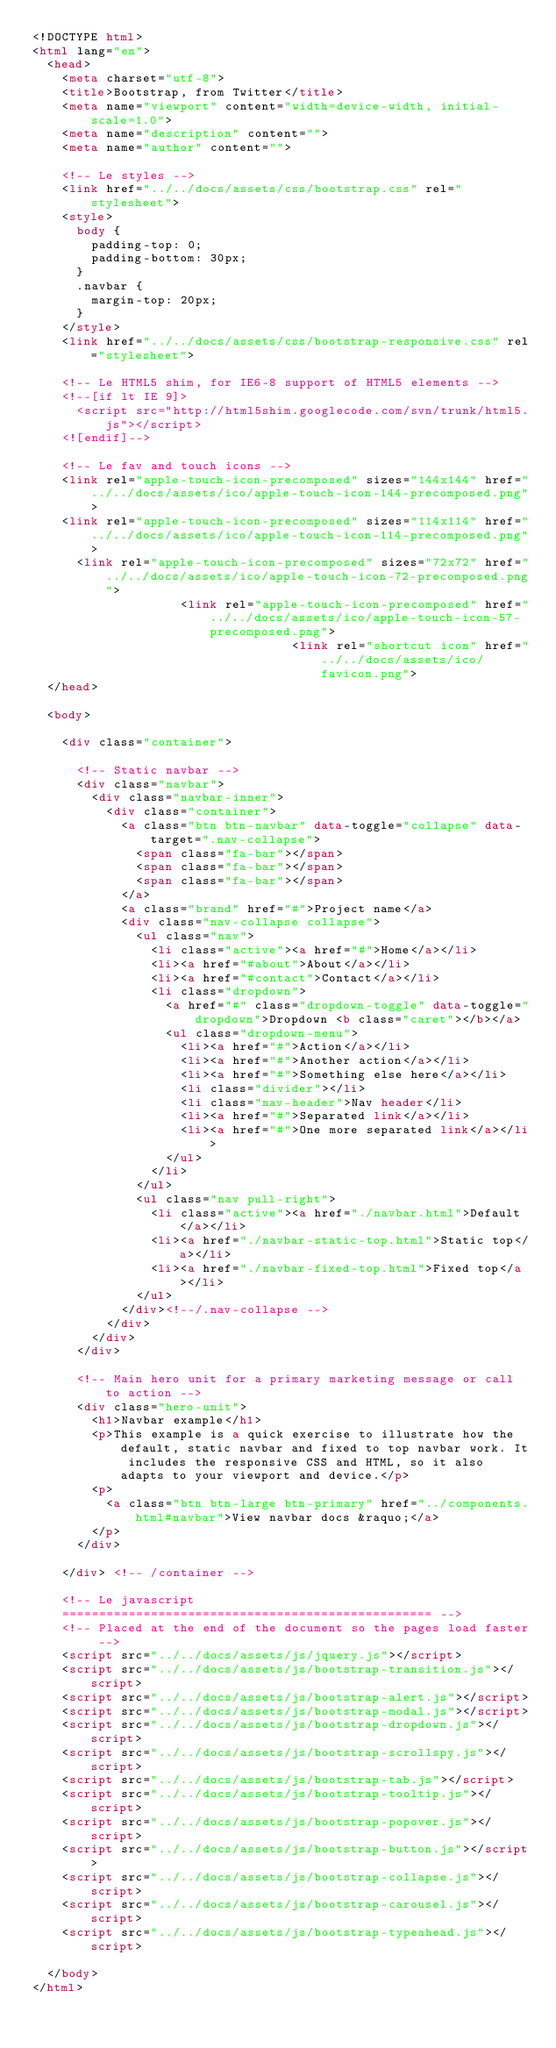Convert code to text. <code><loc_0><loc_0><loc_500><loc_500><_HTML_><!DOCTYPE html>
<html lang="en">
  <head>
    <meta charset="utf-8">
    <title>Bootstrap, from Twitter</title>
    <meta name="viewport" content="width=device-width, initial-scale=1.0">
    <meta name="description" content="">
    <meta name="author" content="">

    <!-- Le styles -->
    <link href="../../docs/assets/css/bootstrap.css" rel="stylesheet">
    <style>
      body {
        padding-top: 0;
        padding-bottom: 30px;
      }
      .navbar {
        margin-top: 20px;
      }
    </style>
    <link href="../../docs/assets/css/bootstrap-responsive.css" rel="stylesheet">

    <!-- Le HTML5 shim, for IE6-8 support of HTML5 elements -->
    <!--[if lt IE 9]>
      <script src="http://html5shim.googlecode.com/svn/trunk/html5.js"></script>
    <![endif]-->

    <!-- Le fav and touch icons -->
    <link rel="apple-touch-icon-precomposed" sizes="144x144" href="../../docs/assets/ico/apple-touch-icon-144-precomposed.png">
    <link rel="apple-touch-icon-precomposed" sizes="114x114" href="../../docs/assets/ico/apple-touch-icon-114-precomposed.png">
      <link rel="apple-touch-icon-precomposed" sizes="72x72" href="../../docs/assets/ico/apple-touch-icon-72-precomposed.png">
                    <link rel="apple-touch-icon-precomposed" href="../../docs/assets/ico/apple-touch-icon-57-precomposed.png">
                                   <link rel="shortcut icon" href="../../docs/assets/ico/favicon.png">
  </head>

  <body>

    <div class="container">

      <!-- Static navbar -->
      <div class="navbar">
        <div class="navbar-inner">
          <div class="container">
            <a class="btn btn-navbar" data-toggle="collapse" data-target=".nav-collapse">
              <span class="fa-bar"></span>
              <span class="fa-bar"></span>
              <span class="fa-bar"></span>
            </a>
            <a class="brand" href="#">Project name</a>
            <div class="nav-collapse collapse">
              <ul class="nav">
                <li class="active"><a href="#">Home</a></li>
                <li><a href="#about">About</a></li>
                <li><a href="#contact">Contact</a></li>
                <li class="dropdown">
                  <a href="#" class="dropdown-toggle" data-toggle="dropdown">Dropdown <b class="caret"></b></a>
                  <ul class="dropdown-menu">
                    <li><a href="#">Action</a></li>
                    <li><a href="#">Another action</a></li>
                    <li><a href="#">Something else here</a></li>
                    <li class="divider"></li>
                    <li class="nav-header">Nav header</li>
                    <li><a href="#">Separated link</a></li>
                    <li><a href="#">One more separated link</a></li>
                  </ul>
                </li>
              </ul>
              <ul class="nav pull-right">
                <li class="active"><a href="./navbar.html">Default</a></li>
                <li><a href="./navbar-static-top.html">Static top</a></li>
                <li><a href="./navbar-fixed-top.html">Fixed top</a></li>
              </ul>
            </div><!--/.nav-collapse -->
          </div>
        </div>
      </div>

      <!-- Main hero unit for a primary marketing message or call to action -->
      <div class="hero-unit">
        <h1>Navbar example</h1>
        <p>This example is a quick exercise to illustrate how the default, static navbar and fixed to top navbar work. It includes the responsive CSS and HTML, so it also adapts to your viewport and device.</p>
        <p>
          <a class="btn btn-large btn-primary" href="../components.html#navbar">View navbar docs &raquo;</a>
        </p>
      </div>

    </div> <!-- /container -->

    <!-- Le javascript
    ================================================== -->
    <!-- Placed at the end of the document so the pages load faster -->
    <script src="../../docs/assets/js/jquery.js"></script>
    <script src="../../docs/assets/js/bootstrap-transition.js"></script>
    <script src="../../docs/assets/js/bootstrap-alert.js"></script>
    <script src="../../docs/assets/js/bootstrap-modal.js"></script>
    <script src="../../docs/assets/js/bootstrap-dropdown.js"></script>
    <script src="../../docs/assets/js/bootstrap-scrollspy.js"></script>
    <script src="../../docs/assets/js/bootstrap-tab.js"></script>
    <script src="../../docs/assets/js/bootstrap-tooltip.js"></script>
    <script src="../../docs/assets/js/bootstrap-popover.js"></script>
    <script src="../../docs/assets/js/bootstrap-button.js"></script>
    <script src="../../docs/assets/js/bootstrap-collapse.js"></script>
    <script src="../../docs/assets/js/bootstrap-carousel.js"></script>
    <script src="../../docs/assets/js/bootstrap-typeahead.js"></script>

  </body>
</html>
</code> 